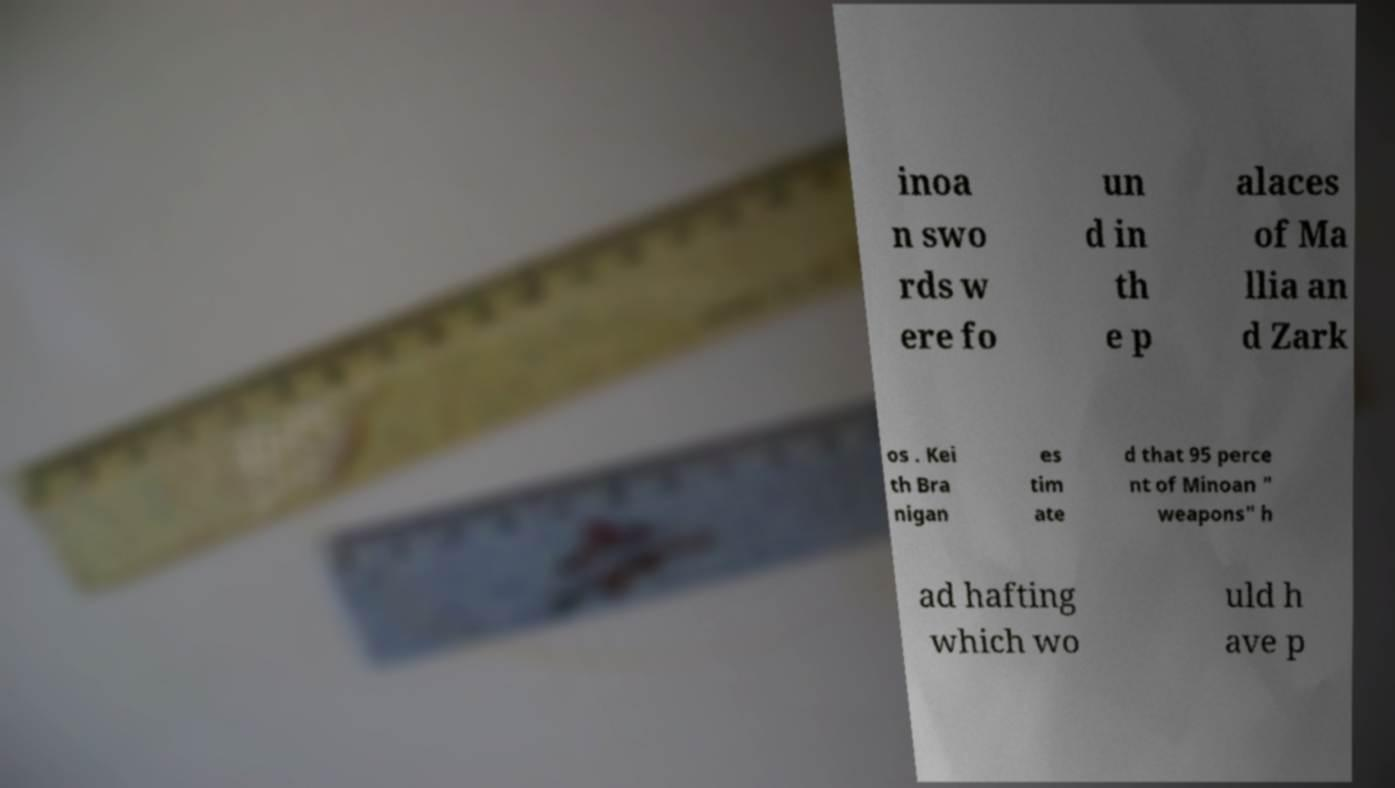Can you read and provide the text displayed in the image?This photo seems to have some interesting text. Can you extract and type it out for me? inoa n swo rds w ere fo un d in th e p alaces of Ma llia an d Zark os . Kei th Bra nigan es tim ate d that 95 perce nt of Minoan " weapons" h ad hafting which wo uld h ave p 